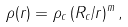<formula> <loc_0><loc_0><loc_500><loc_500>\rho ( r ) = \rho _ { c } \, ( R _ { c } / r ) ^ { m } \, ,</formula> 